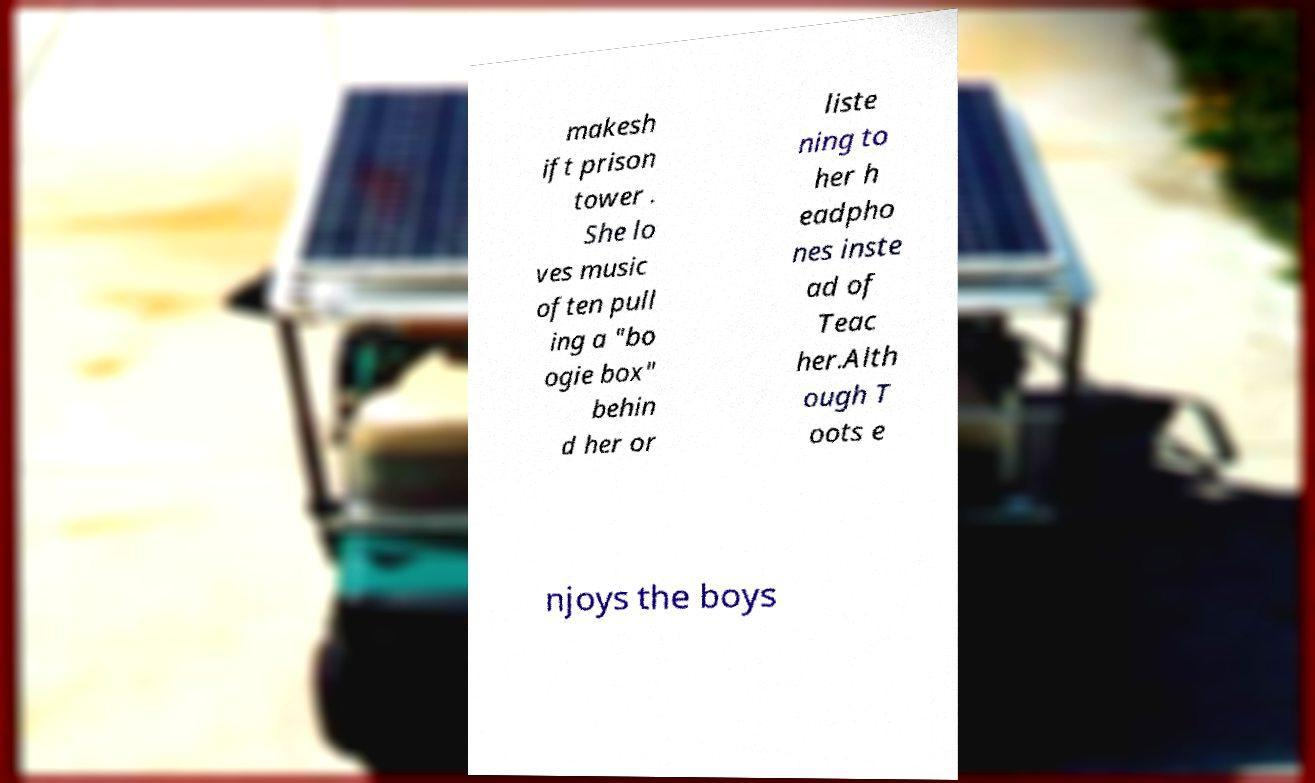What messages or text are displayed in this image? I need them in a readable, typed format. makesh ift prison tower . She lo ves music often pull ing a "bo ogie box" behin d her or liste ning to her h eadpho nes inste ad of Teac her.Alth ough T oots e njoys the boys 